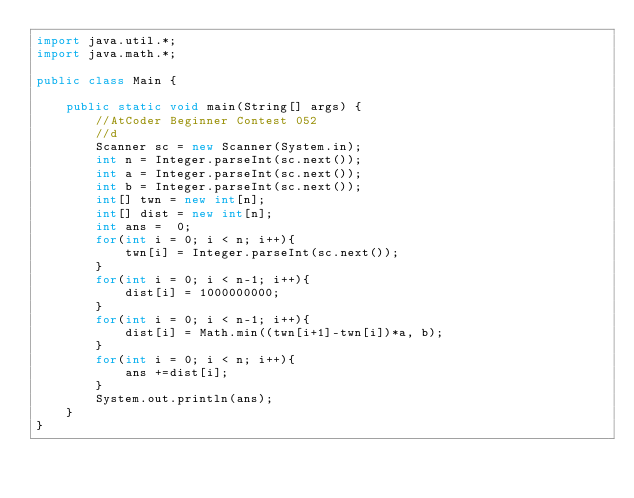<code> <loc_0><loc_0><loc_500><loc_500><_Java_>import java.util.*;
import java.math.*;

public class Main {

    public static void main(String[] args) {
        //AtCoder Beginner Contest 052
        //d
        Scanner sc = new Scanner(System.in);
        int n = Integer.parseInt(sc.next());
        int a = Integer.parseInt(sc.next());
        int b = Integer.parseInt(sc.next());
        int[] twn = new int[n];
        int[] dist = new int[n];
        int ans =  0;
        for(int i = 0; i < n; i++){
            twn[i] = Integer.parseInt(sc.next());
        }
        for(int i = 0; i < n-1; i++){
            dist[i] = 1000000000;
        }
        for(int i = 0; i < n-1; i++){
            dist[i] = Math.min((twn[i+1]-twn[i])*a, b);
        }
        for(int i = 0; i < n; i++){
            ans +=dist[i];
        }
        System.out.println(ans);
    }
}</code> 